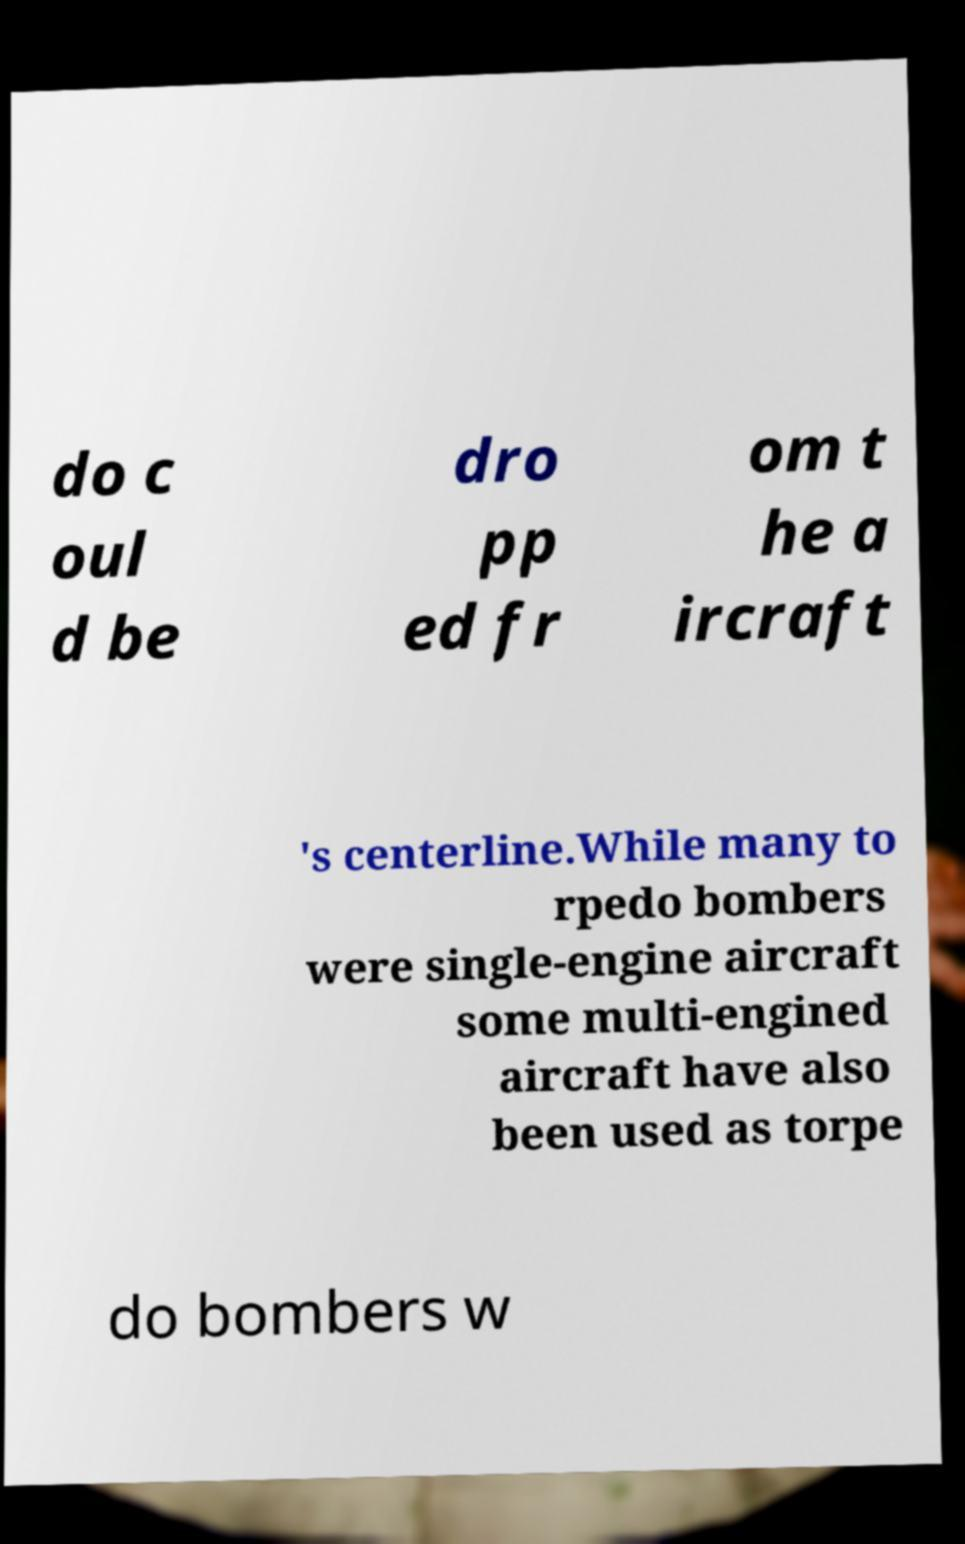Please read and relay the text visible in this image. What does it say? do c oul d be dro pp ed fr om t he a ircraft 's centerline.While many to rpedo bombers were single-engine aircraft some multi-engined aircraft have also been used as torpe do bombers w 